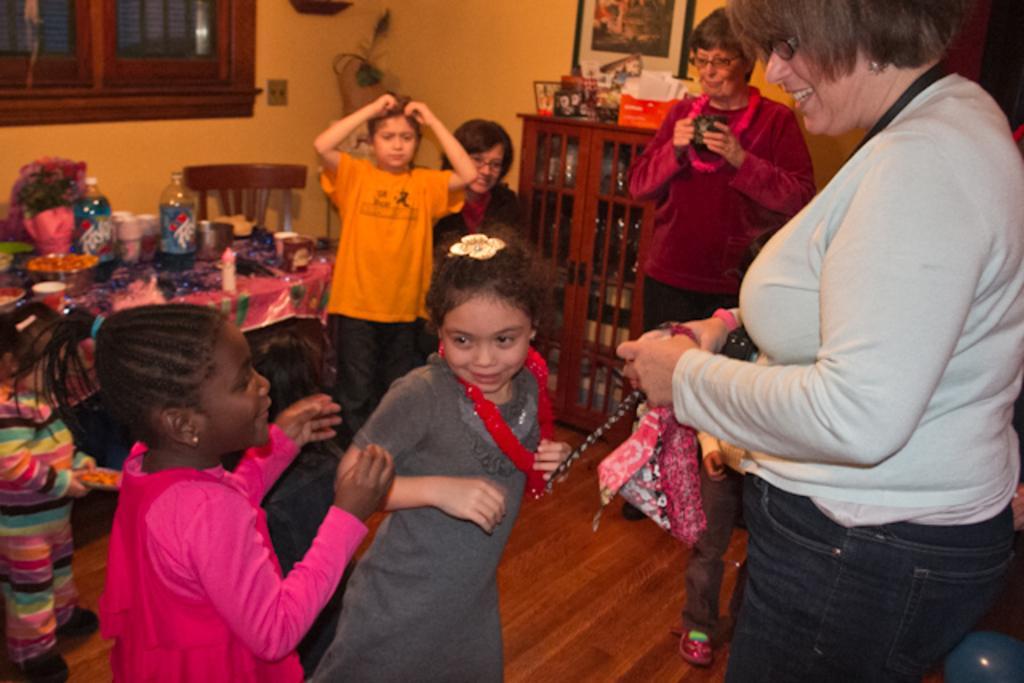How would you summarize this image in a sentence or two? On this table there are containers, bottles and things. Beside this table there is a chair and window. In this race there are things. Picture is on the wall. Here we can see people. This woman is holding a camera.  